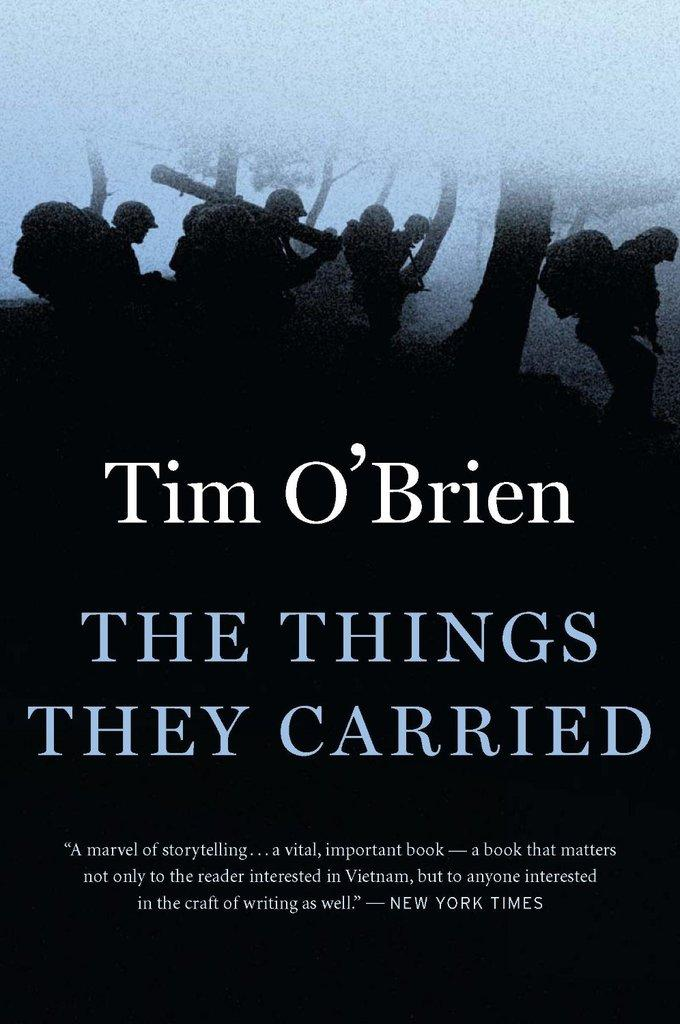<image>
Present a compact description of the photo's key features. A Tim O'Brien book cover includes images of soldiers walking through the woods. 